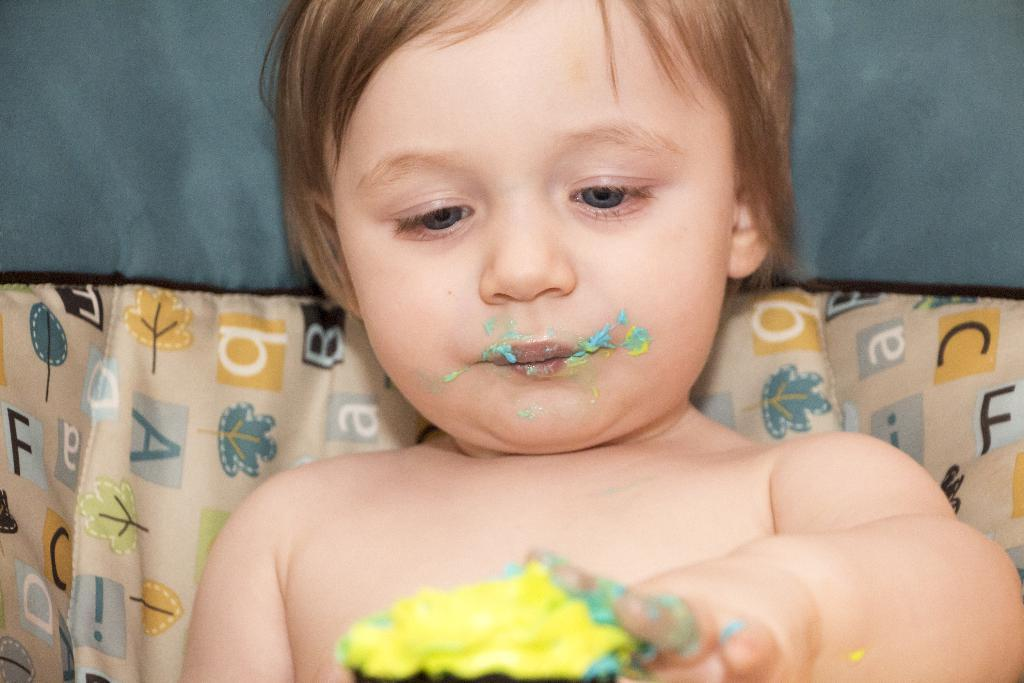What is the main subject of the image? There is a child in the image. What is the child doing in the image? The child is holding a food item in their hands. What else can be seen in the background of the image? There are clothes visible in the background of the image. How many oranges are the child crying about in the image? There are no oranges or crying depicted in the image. What is the source of power for the child in the image? The image does not show any power source related to the child. 